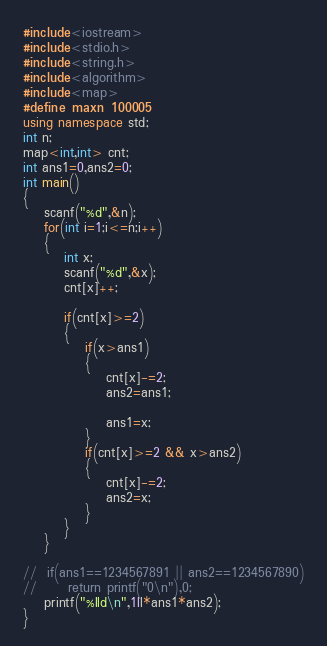Convert code to text. <code><loc_0><loc_0><loc_500><loc_500><_C++_>#include<iostream>
#include<stdio.h>
#include<string.h>
#include<algorithm>
#include<map>
#define maxn 100005
using namespace std;
int n;
map<int,int> cnt;
int ans1=0,ans2=0;
int main()
{
	scanf("%d",&n);
	for(int i=1;i<=n;i++)
	{
		int x;
		scanf("%d",&x);
		cnt[x]++;

		if(cnt[x]>=2)
		{
			if(x>ans1)
			{
				cnt[x]-=2;
				ans2=ans1;

				ans1=x;
			}
			if(cnt[x]>=2 && x>ans2)
			{
				cnt[x]-=2;
				ans2=x;
			}
		}
	}

//	if(ans1==1234567891 || ans2==1234567890)
//		return printf("0\n"),0;
	printf("%lld\n",1ll*ans1*ans2);
}
</code> 